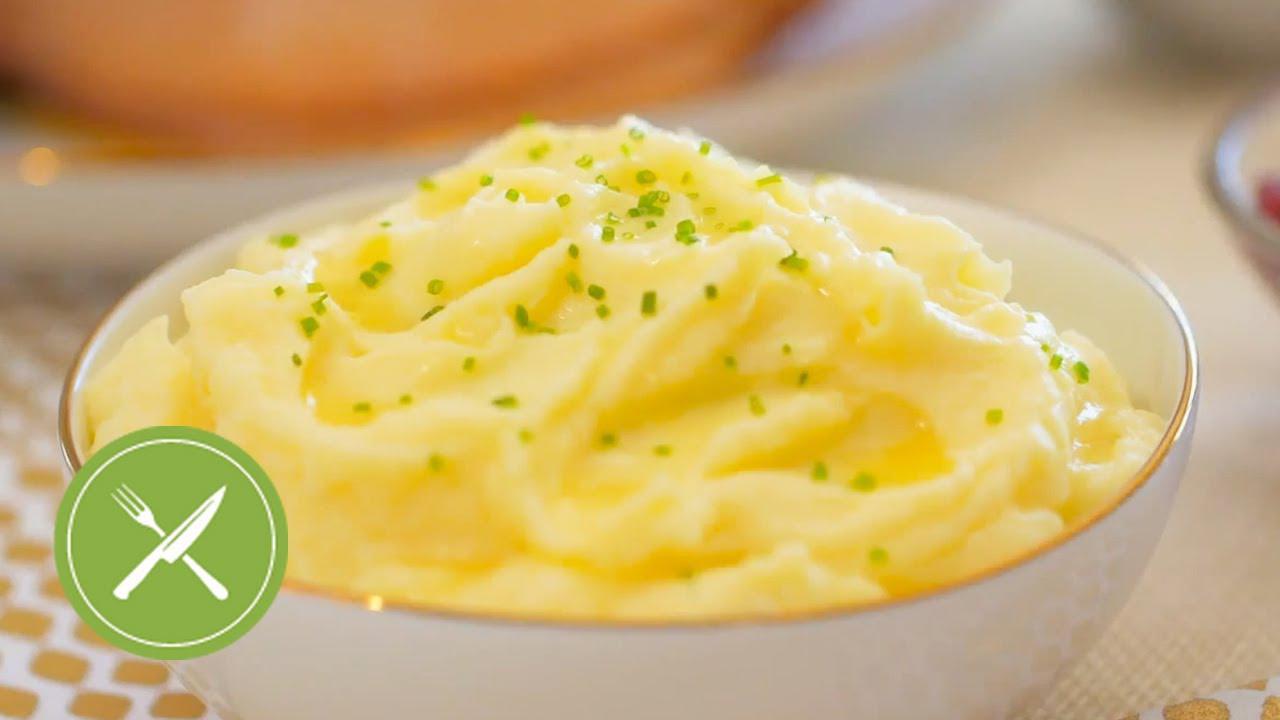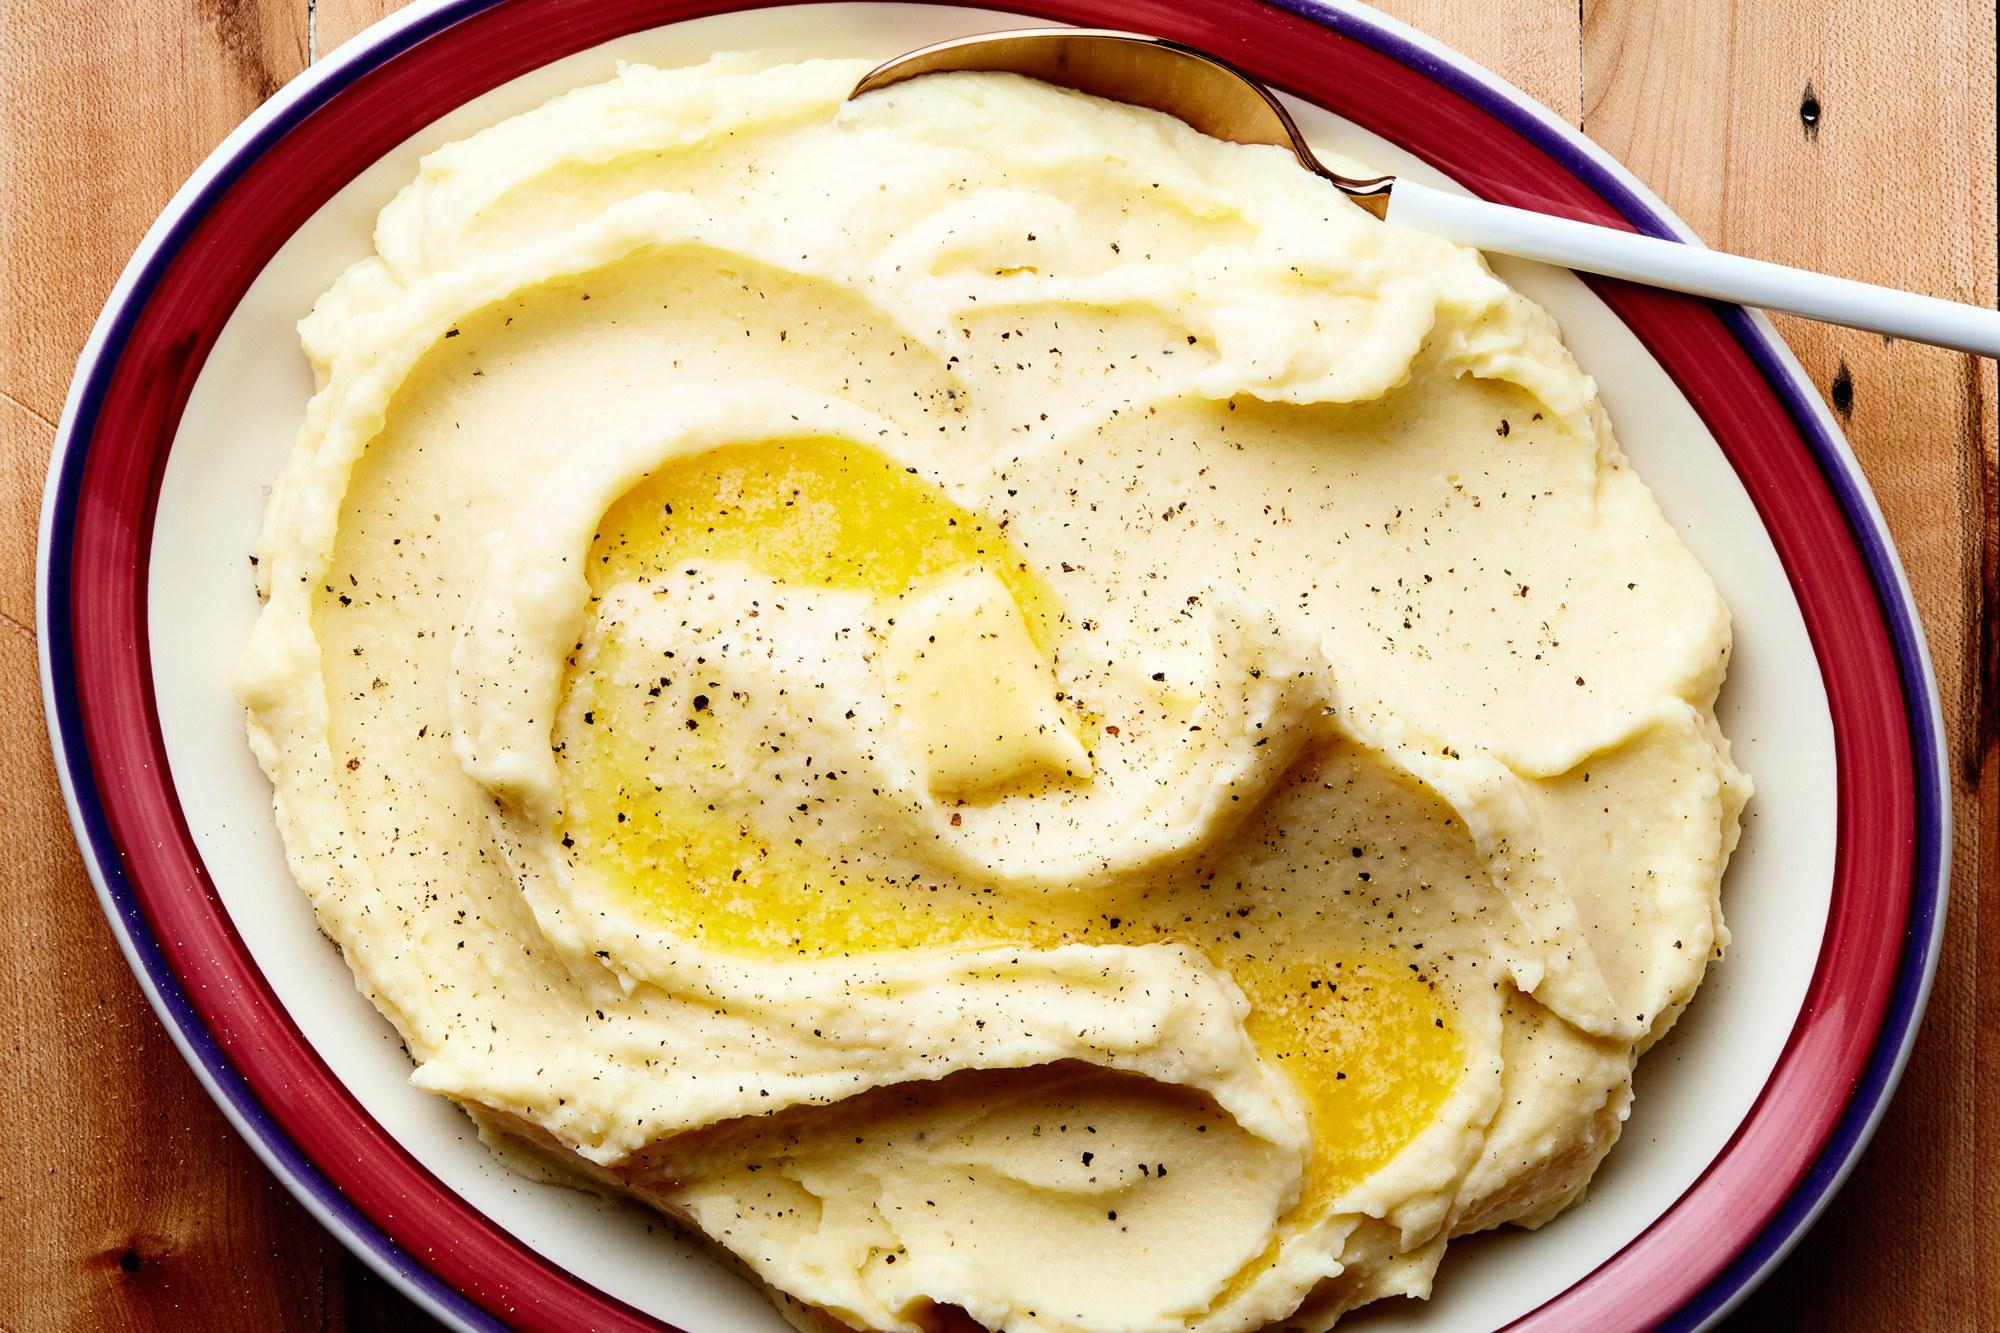The first image is the image on the left, the second image is the image on the right. Given the left and right images, does the statement "An unmelted pat of butter sits in the dish in one of the images." hold true? Answer yes or no. No. The first image is the image on the left, the second image is the image on the right. Given the left and right images, does the statement "An image contains mashed potatoes with a spoon inside it." hold true? Answer yes or no. Yes. 